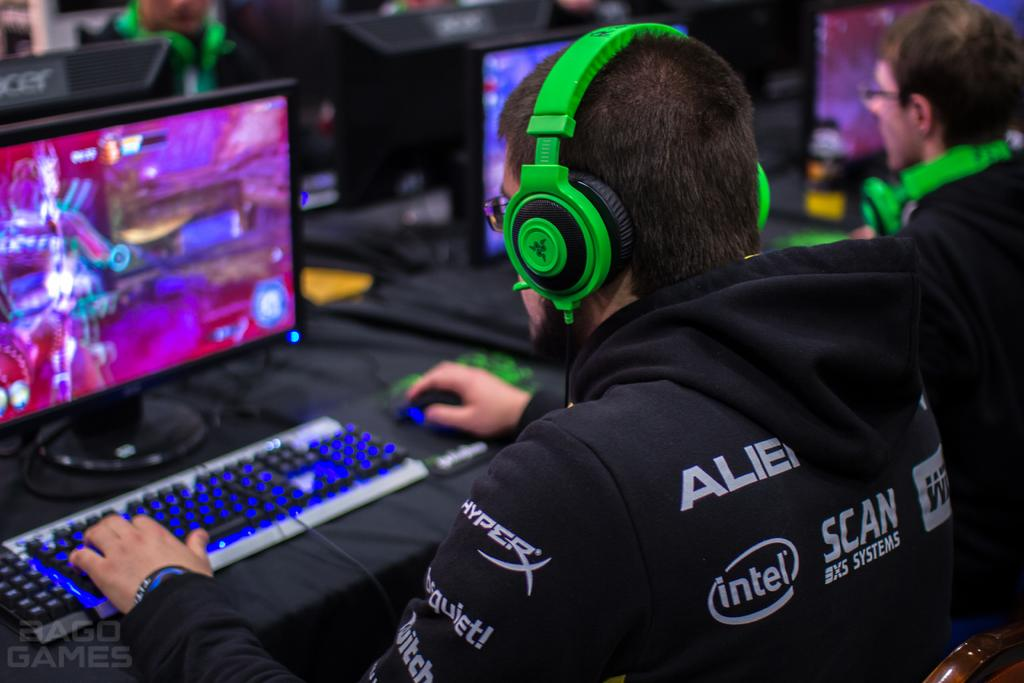<image>
Provide a brief description of the given image. A person wearing green headphones and a black sweatshirt with Intel written on it. 